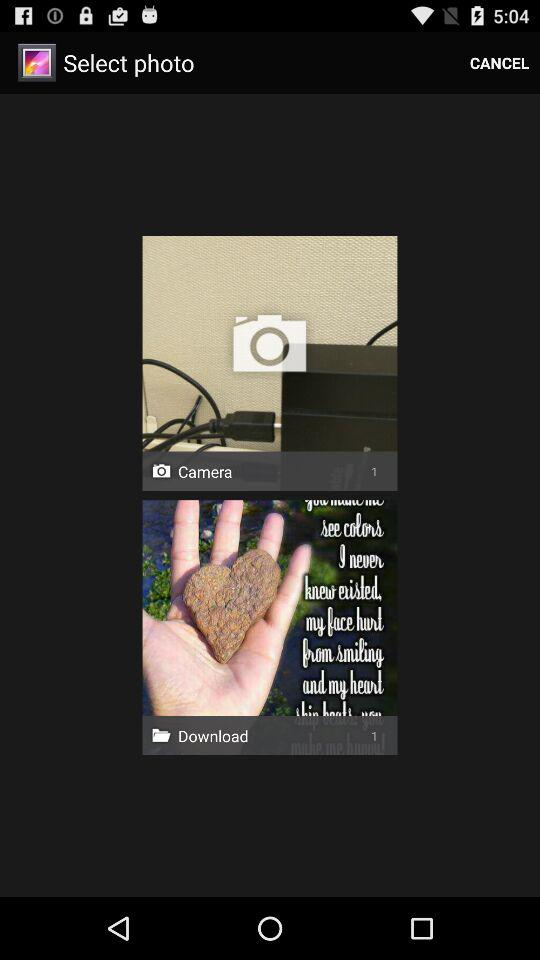Who took the photos?
When the provided information is insufficient, respond with <no answer>. <no answer> 